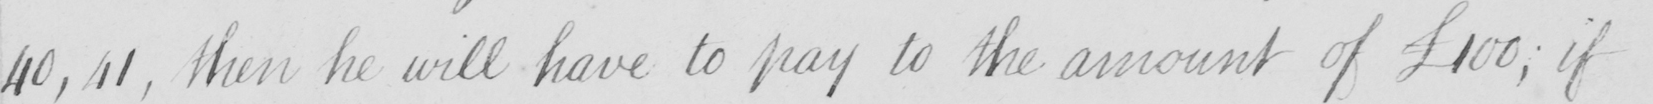What is written in this line of handwriting? 40 , 41 , then he will have to pay to the amount of  £100 ; if 